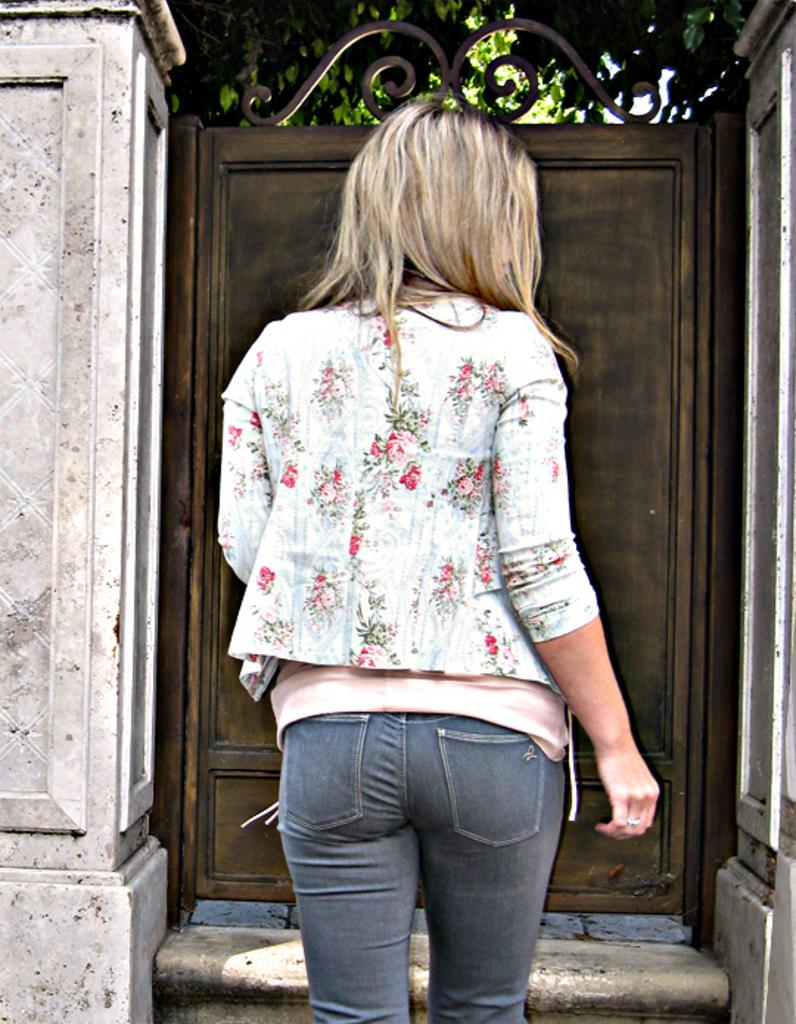Who is the main subject in the image? There is a woman in the image. What is the woman doing in the image? The woman is walking towards a gate. Can you describe the gate in the image? There are two pillars on both sides of the gate. What can be seen behind the gate in the image? There is a tree behind the gate. How many chins does the woman have in the image? The number of chins cannot be determined from the image, as it only shows the woman's profile. Can you tell me how many rabbits are hiding behind the tree in the image? There are no rabbits present in the image; it only shows a tree behind the gate. 